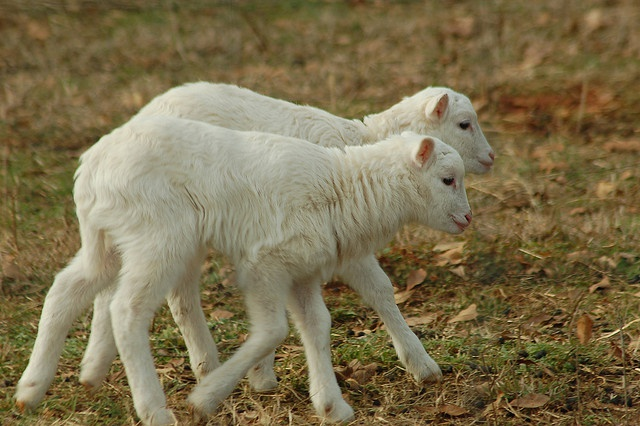Describe the objects in this image and their specific colors. I can see sheep in olive, darkgray, gray, and lightgray tones and sheep in olive, darkgray, gray, and lightgray tones in this image. 